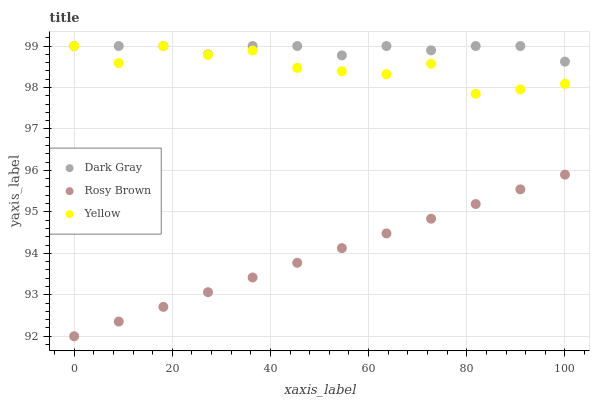Does Rosy Brown have the minimum area under the curve?
Answer yes or no. Yes. Does Dark Gray have the maximum area under the curve?
Answer yes or no. Yes. Does Yellow have the minimum area under the curve?
Answer yes or no. No. Does Yellow have the maximum area under the curve?
Answer yes or no. No. Is Rosy Brown the smoothest?
Answer yes or no. Yes. Is Yellow the roughest?
Answer yes or no. Yes. Is Yellow the smoothest?
Answer yes or no. No. Is Rosy Brown the roughest?
Answer yes or no. No. Does Rosy Brown have the lowest value?
Answer yes or no. Yes. Does Yellow have the lowest value?
Answer yes or no. No. Does Yellow have the highest value?
Answer yes or no. Yes. Does Rosy Brown have the highest value?
Answer yes or no. No. Is Rosy Brown less than Yellow?
Answer yes or no. Yes. Is Dark Gray greater than Rosy Brown?
Answer yes or no. Yes. Does Dark Gray intersect Yellow?
Answer yes or no. Yes. Is Dark Gray less than Yellow?
Answer yes or no. No. Is Dark Gray greater than Yellow?
Answer yes or no. No. Does Rosy Brown intersect Yellow?
Answer yes or no. No. 